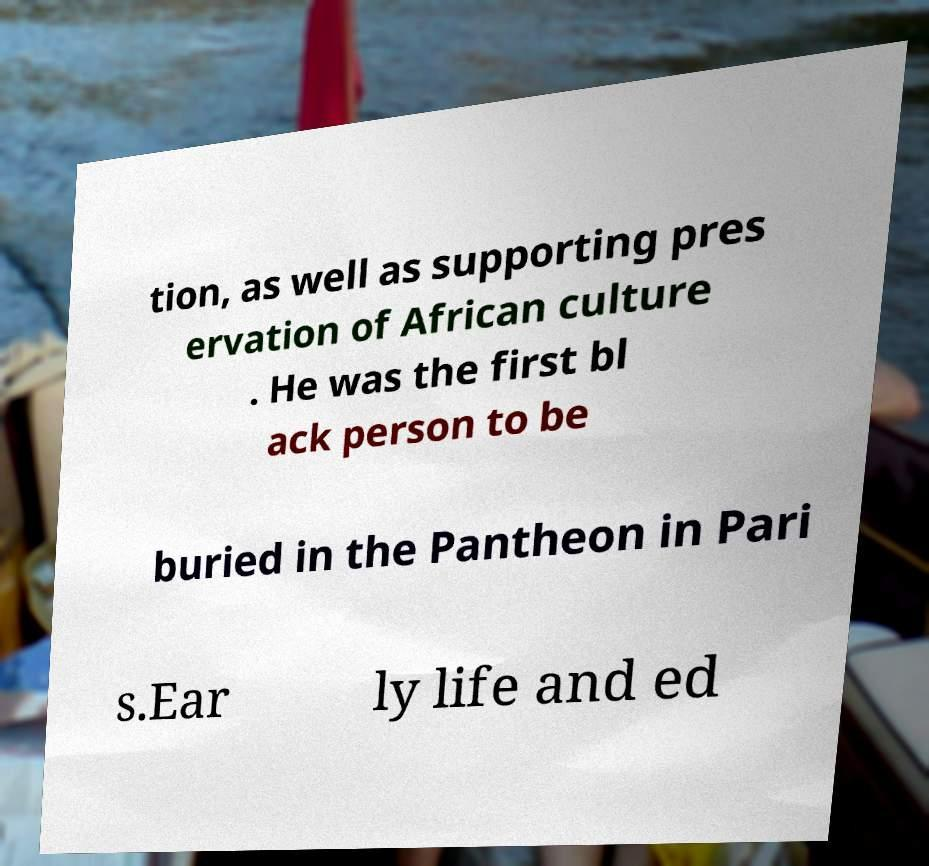For documentation purposes, I need the text within this image transcribed. Could you provide that? tion, as well as supporting pres ervation of African culture . He was the first bl ack person to be buried in the Pantheon in Pari s.Ear ly life and ed 